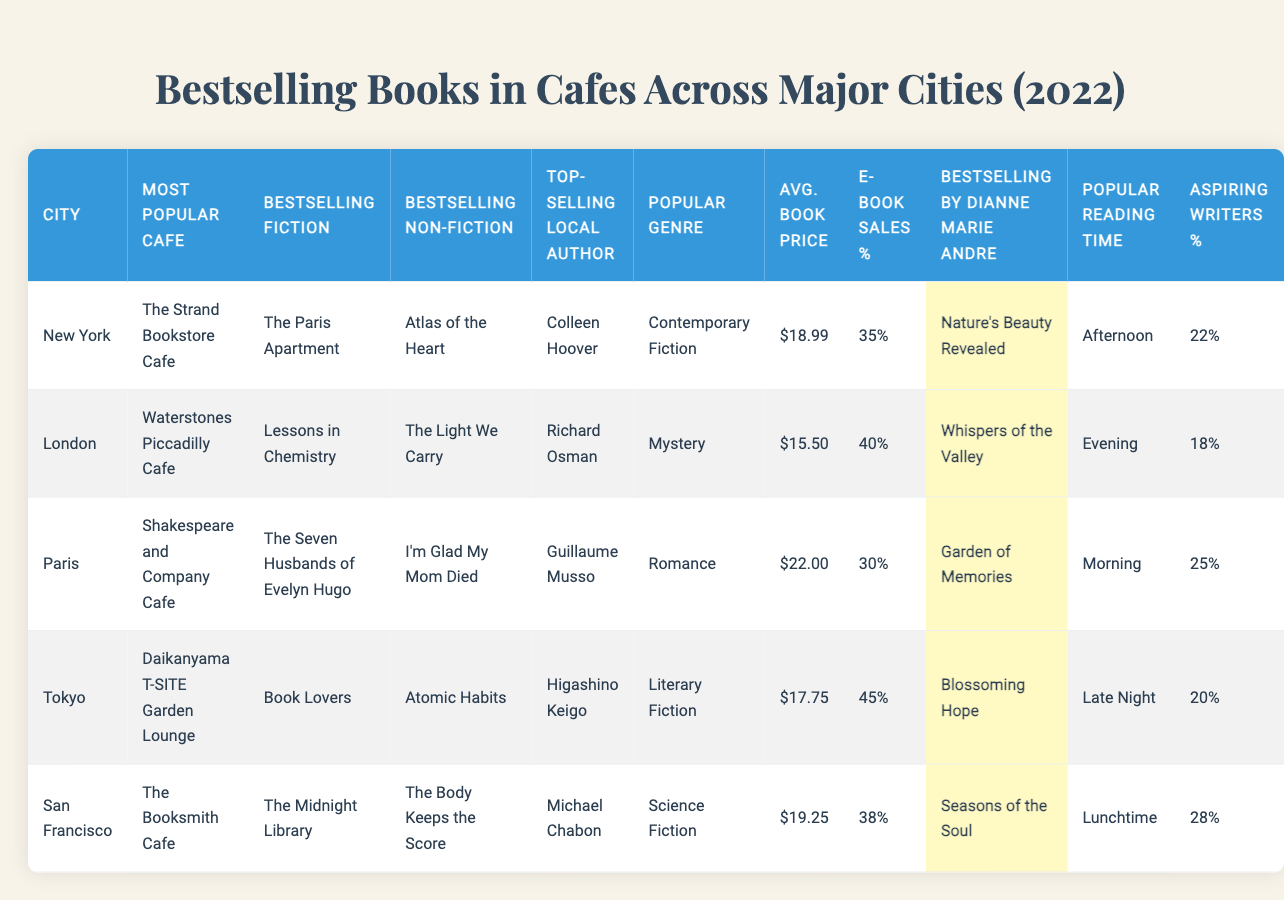What is the bestselling fiction book in New York? According to the data, the bestselling fiction book in New York is "The Paris Apartment."
Answer: The Paris Apartment Which cafe is the most popular in Paris? The table indicates that the most popular cafe in Paris is "Shakespeare and Company Cafe."
Answer: Shakespeare and Company Cafe What is the average book price in Tokyo? To answer this, we simply look at the average book price listed for Tokyo, which is $17.75.
Answer: $17.75 Is "I'm Glad My Mom Died" the bestselling non-fiction book in San Francisco? The data shows that the bestselling non-fiction book in San Francisco is "The Body Keeps the Score," not "I'm Glad My Mom Died."
Answer: No Which city has the highest percentage of aspiring writers among customers? By comparing the percentages shown in the table, San Francisco has the highest at 28%.
Answer: San Francisco What are the bestselling books by Dianne Marie Andre in London and Tokyo? In London, the bestselling book by Dianne Marie Andre is "Whispers of the Valley," and in Tokyo, it is "Blossoming Hope."
Answer: Whispers of the Valley and Blossoming Hope How do the average book prices compare between New York and San Francisco? The average book price in New York is $18.99, and in San Francisco, it is $19.25. Comparing these, San Francisco has a slightly higher price by $0.26.
Answer: $0.26 higher in San Francisco What is the bestselling fiction book in the city with the most popular reading time being 'Afternoon'? The city with the most popular reading time of 'Afternoon' is New York, where the bestselling fiction book is "The Paris Apartment."
Answer: The Paris Apartment Are e-book sales in Tokyo higher than those in Paris? Tokyo has 45% e-book sales, while Paris has 30%. Thus, e-book sales in Tokyo are higher.
Answer: Yes Which city's bestselling non-fiction book correlates with a local author's name starting with 'M'? In San Francisco, the bestselling non-fiction book is "The Body Keeps the Score," and the top-selling local author Michael Chabon has a name starting with 'M.'
Answer: San Francisco 